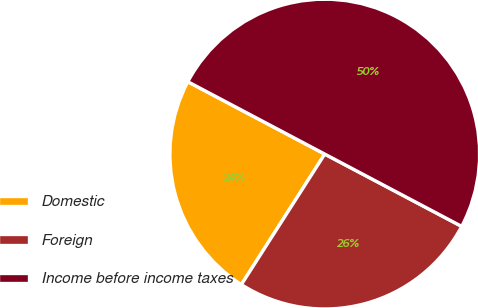<chart> <loc_0><loc_0><loc_500><loc_500><pie_chart><fcel>Domestic<fcel>Foreign<fcel>Income before income taxes<nl><fcel>23.69%<fcel>26.32%<fcel>50.0%<nl></chart> 